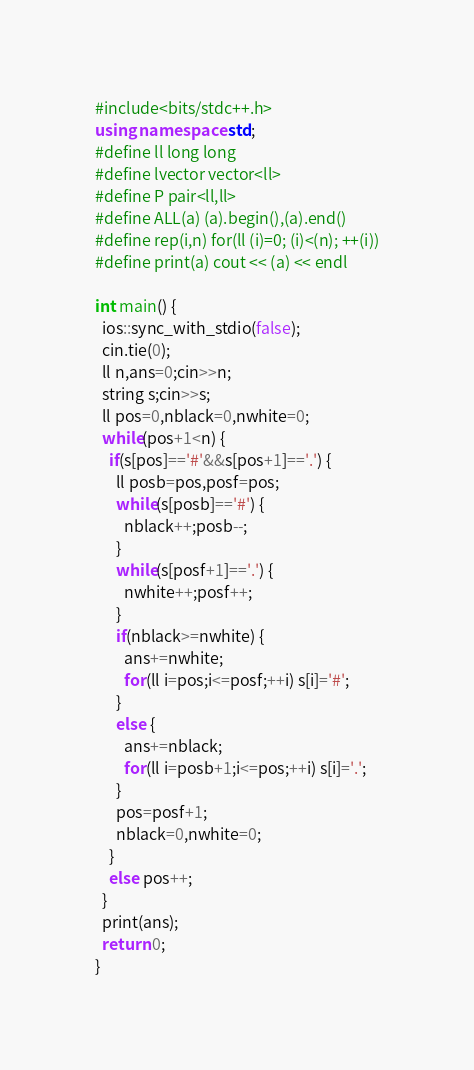Convert code to text. <code><loc_0><loc_0><loc_500><loc_500><_C++_>#include<bits/stdc++.h>
using namespace std;
#define ll long long
#define lvector vector<ll>
#define P pair<ll,ll> 
#define ALL(a) (a).begin(),(a).end()
#define rep(i,n) for(ll (i)=0; (i)<(n); ++(i))
#define print(a) cout << (a) << endl

int main() {
  ios::sync_with_stdio(false);
  cin.tie(0);
  ll n,ans=0;cin>>n;
  string s;cin>>s;
  ll pos=0,nblack=0,nwhite=0;
  while(pos+1<n) {
    if(s[pos]=='#'&&s[pos+1]=='.') {
      ll posb=pos,posf=pos;
      while(s[posb]=='#') {
        nblack++;posb--;
      }
      while(s[posf+1]=='.') {
        nwhite++;posf++;
      }
      if(nblack>=nwhite) {
        ans+=nwhite;
        for(ll i=pos;i<=posf;++i) s[i]='#';
      }
      else {
        ans+=nblack;
        for(ll i=posb+1;i<=pos;++i) s[i]='.';
      }
      pos=posf+1;
      nblack=0,nwhite=0;
    }
    else pos++;
  }
  print(ans);
  return 0;
}</code> 